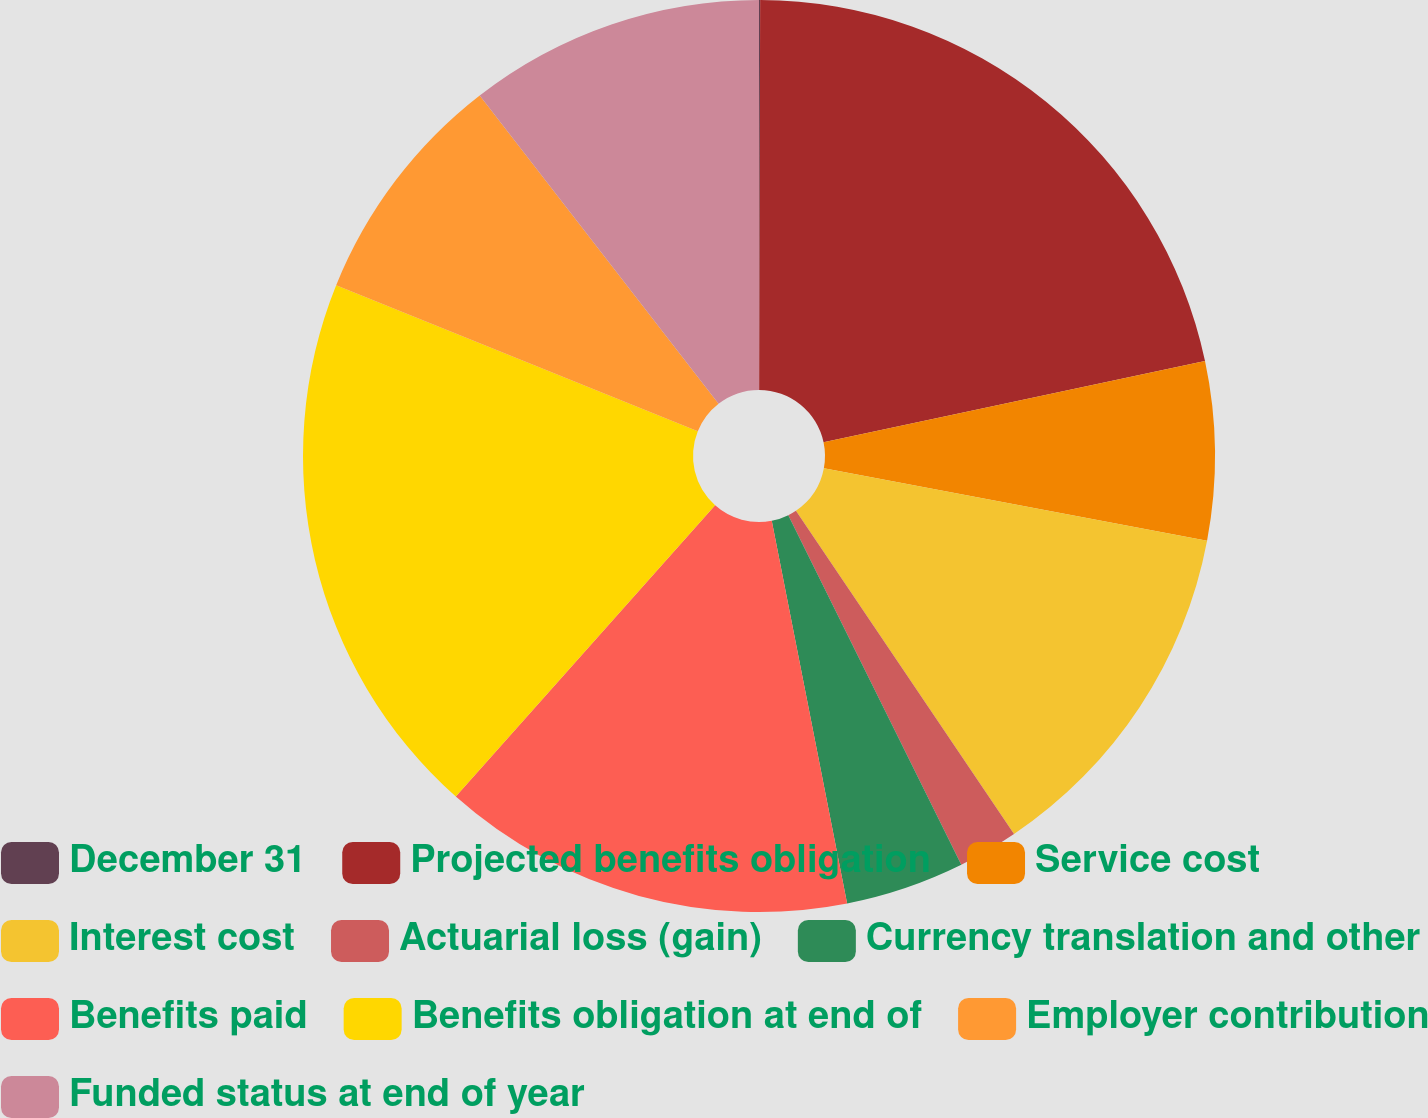<chart> <loc_0><loc_0><loc_500><loc_500><pie_chart><fcel>December 31<fcel>Projected benefits obligation<fcel>Service cost<fcel>Interest cost<fcel>Actuarial loss (gain)<fcel>Currency translation and other<fcel>Benefits paid<fcel>Benefits obligation at end of<fcel>Employer contribution<fcel>Funded status at end of year<nl><fcel>0.04%<fcel>21.62%<fcel>6.31%<fcel>12.58%<fcel>2.13%<fcel>4.22%<fcel>14.67%<fcel>19.53%<fcel>8.4%<fcel>10.49%<nl></chart> 